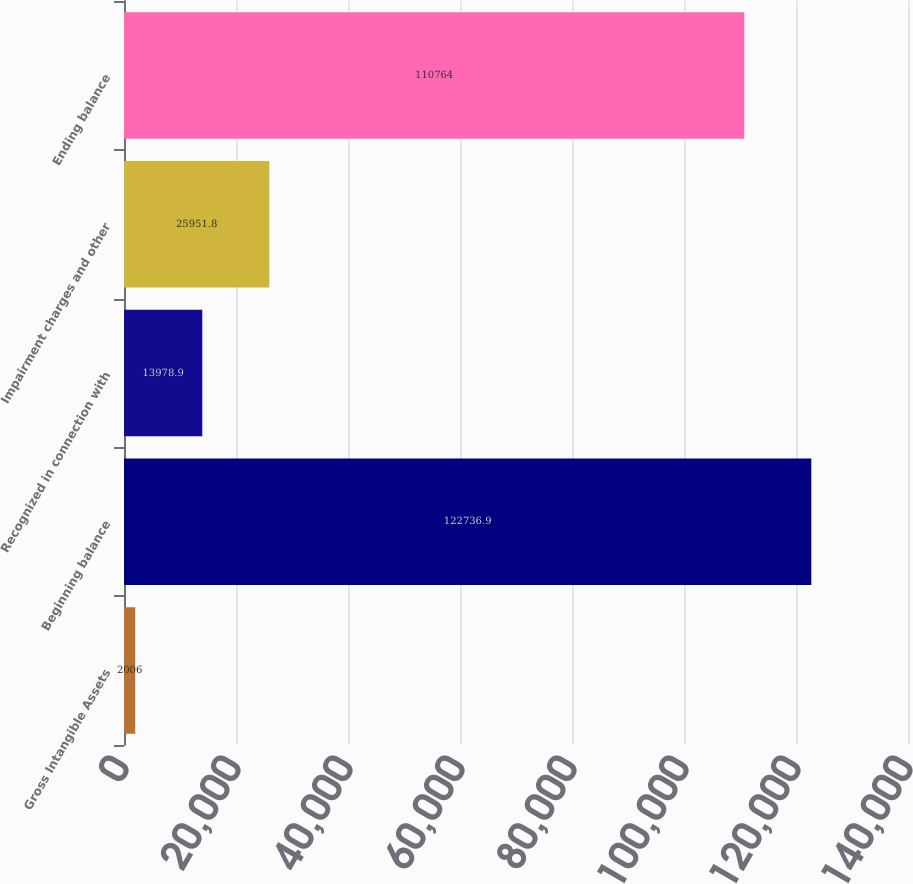Convert chart to OTSL. <chart><loc_0><loc_0><loc_500><loc_500><bar_chart><fcel>Gross Intangible Assets<fcel>Beginning balance<fcel>Recognized in connection with<fcel>Impairment charges and other<fcel>Ending balance<nl><fcel>2006<fcel>122737<fcel>13978.9<fcel>25951.8<fcel>110764<nl></chart> 